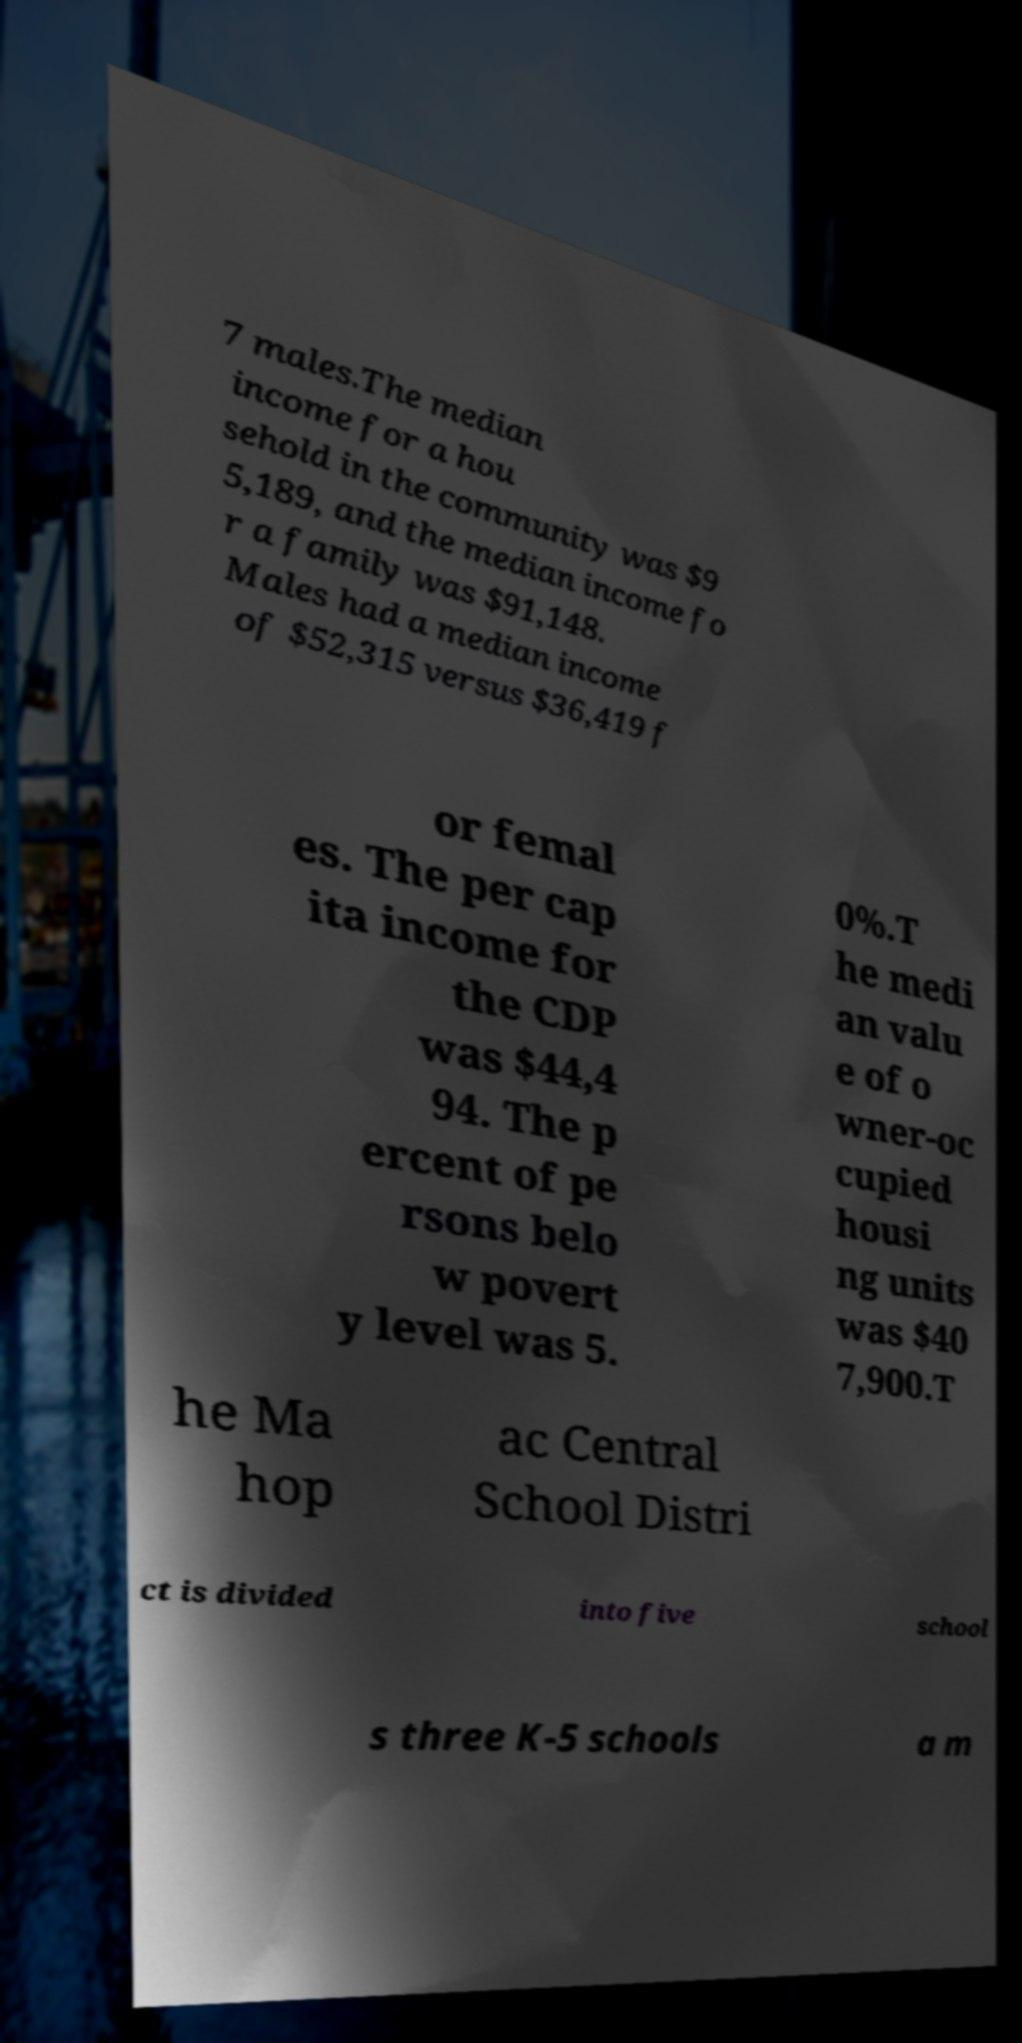Could you extract and type out the text from this image? 7 males.The median income for a hou sehold in the community was $9 5,189, and the median income fo r a family was $91,148. Males had a median income of $52,315 versus $36,419 f or femal es. The per cap ita income for the CDP was $44,4 94. The p ercent of pe rsons belo w povert y level was 5. 0%.T he medi an valu e of o wner-oc cupied housi ng units was $40 7,900.T he Ma hop ac Central School Distri ct is divided into five school s three K-5 schools a m 